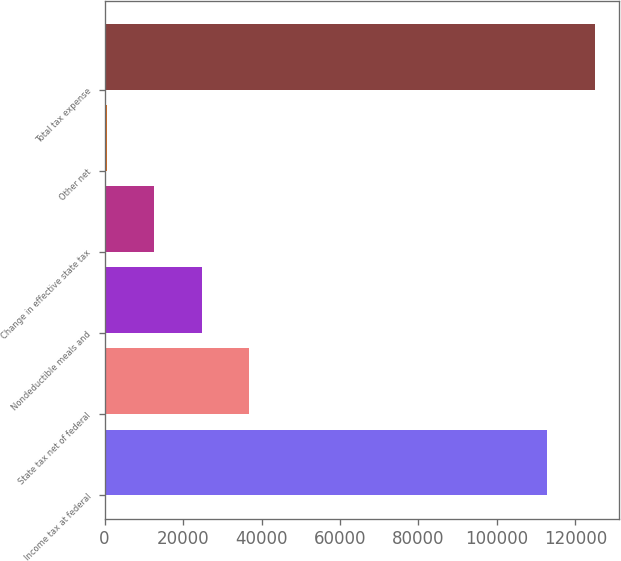Convert chart to OTSL. <chart><loc_0><loc_0><loc_500><loc_500><bar_chart><fcel>Income tax at federal<fcel>State tax net of federal<fcel>Nondeductible meals and<fcel>Change in effective state tax<fcel>Other net<fcel>Total tax expense<nl><fcel>112782<fcel>36856.2<fcel>24743.8<fcel>12631.4<fcel>519<fcel>124894<nl></chart> 